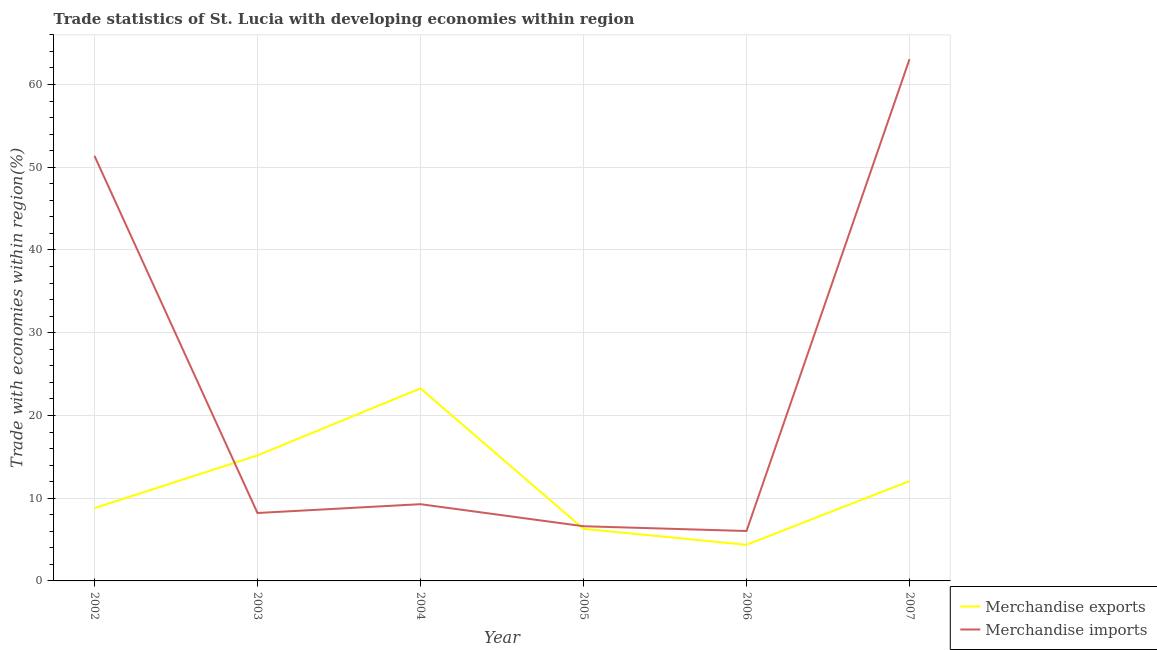How many different coloured lines are there?
Provide a succinct answer. 2. What is the merchandise exports in 2003?
Your answer should be very brief. 15.17. Across all years, what is the maximum merchandise exports?
Make the answer very short. 23.27. Across all years, what is the minimum merchandise exports?
Your answer should be very brief. 4.37. In which year was the merchandise imports maximum?
Make the answer very short. 2007. What is the total merchandise exports in the graph?
Give a very brief answer. 69.97. What is the difference between the merchandise exports in 2003 and that in 2007?
Give a very brief answer. 3.1. What is the difference between the merchandise exports in 2003 and the merchandise imports in 2007?
Offer a very short reply. -47.9. What is the average merchandise imports per year?
Your response must be concise. 24.1. In the year 2005, what is the difference between the merchandise exports and merchandise imports?
Give a very brief answer. -0.32. In how many years, is the merchandise imports greater than 58 %?
Provide a short and direct response. 1. What is the ratio of the merchandise imports in 2006 to that in 2007?
Provide a short and direct response. 0.1. Is the merchandise exports in 2005 less than that in 2006?
Keep it short and to the point. No. What is the difference between the highest and the second highest merchandise imports?
Ensure brevity in your answer.  11.69. What is the difference between the highest and the lowest merchandise exports?
Offer a very short reply. 18.9. In how many years, is the merchandise exports greater than the average merchandise exports taken over all years?
Give a very brief answer. 3. Does the merchandise imports monotonically increase over the years?
Offer a terse response. No. Where does the legend appear in the graph?
Your answer should be very brief. Bottom right. How are the legend labels stacked?
Keep it short and to the point. Vertical. What is the title of the graph?
Your response must be concise. Trade statistics of St. Lucia with developing economies within region. What is the label or title of the X-axis?
Provide a succinct answer. Year. What is the label or title of the Y-axis?
Offer a very short reply. Trade with economies within region(%). What is the Trade with economies within region(%) of Merchandise exports in 2002?
Offer a very short reply. 8.8. What is the Trade with economies within region(%) in Merchandise imports in 2002?
Keep it short and to the point. 51.38. What is the Trade with economies within region(%) of Merchandise exports in 2003?
Provide a succinct answer. 15.17. What is the Trade with economies within region(%) of Merchandise imports in 2003?
Give a very brief answer. 8.21. What is the Trade with economies within region(%) of Merchandise exports in 2004?
Give a very brief answer. 23.27. What is the Trade with economies within region(%) of Merchandise imports in 2004?
Give a very brief answer. 9.27. What is the Trade with economies within region(%) in Merchandise exports in 2005?
Keep it short and to the point. 6.3. What is the Trade with economies within region(%) of Merchandise imports in 2005?
Your answer should be very brief. 6.61. What is the Trade with economies within region(%) of Merchandise exports in 2006?
Provide a succinct answer. 4.37. What is the Trade with economies within region(%) of Merchandise imports in 2006?
Your answer should be compact. 6.03. What is the Trade with economies within region(%) in Merchandise exports in 2007?
Provide a succinct answer. 12.07. What is the Trade with economies within region(%) of Merchandise imports in 2007?
Your response must be concise. 63.07. Across all years, what is the maximum Trade with economies within region(%) of Merchandise exports?
Ensure brevity in your answer.  23.27. Across all years, what is the maximum Trade with economies within region(%) in Merchandise imports?
Ensure brevity in your answer.  63.07. Across all years, what is the minimum Trade with economies within region(%) in Merchandise exports?
Ensure brevity in your answer.  4.37. Across all years, what is the minimum Trade with economies within region(%) in Merchandise imports?
Make the answer very short. 6.03. What is the total Trade with economies within region(%) of Merchandise exports in the graph?
Your response must be concise. 69.97. What is the total Trade with economies within region(%) of Merchandise imports in the graph?
Your answer should be very brief. 144.57. What is the difference between the Trade with economies within region(%) in Merchandise exports in 2002 and that in 2003?
Provide a short and direct response. -6.37. What is the difference between the Trade with economies within region(%) in Merchandise imports in 2002 and that in 2003?
Ensure brevity in your answer.  43.17. What is the difference between the Trade with economies within region(%) of Merchandise exports in 2002 and that in 2004?
Your response must be concise. -14.47. What is the difference between the Trade with economies within region(%) of Merchandise imports in 2002 and that in 2004?
Your answer should be compact. 42.1. What is the difference between the Trade with economies within region(%) of Merchandise exports in 2002 and that in 2005?
Your answer should be compact. 2.5. What is the difference between the Trade with economies within region(%) of Merchandise imports in 2002 and that in 2005?
Make the answer very short. 44.77. What is the difference between the Trade with economies within region(%) of Merchandise exports in 2002 and that in 2006?
Offer a very short reply. 4.43. What is the difference between the Trade with economies within region(%) in Merchandise imports in 2002 and that in 2006?
Offer a very short reply. 45.35. What is the difference between the Trade with economies within region(%) in Merchandise exports in 2002 and that in 2007?
Your answer should be compact. -3.27. What is the difference between the Trade with economies within region(%) of Merchandise imports in 2002 and that in 2007?
Make the answer very short. -11.69. What is the difference between the Trade with economies within region(%) in Merchandise exports in 2003 and that in 2004?
Offer a very short reply. -8.1. What is the difference between the Trade with economies within region(%) of Merchandise imports in 2003 and that in 2004?
Keep it short and to the point. -1.06. What is the difference between the Trade with economies within region(%) of Merchandise exports in 2003 and that in 2005?
Offer a terse response. 8.88. What is the difference between the Trade with economies within region(%) in Merchandise imports in 2003 and that in 2005?
Offer a terse response. 1.6. What is the difference between the Trade with economies within region(%) of Merchandise exports in 2003 and that in 2006?
Your answer should be very brief. 10.8. What is the difference between the Trade with economies within region(%) in Merchandise imports in 2003 and that in 2006?
Offer a very short reply. 2.18. What is the difference between the Trade with economies within region(%) of Merchandise exports in 2003 and that in 2007?
Offer a terse response. 3.1. What is the difference between the Trade with economies within region(%) in Merchandise imports in 2003 and that in 2007?
Your answer should be compact. -54.86. What is the difference between the Trade with economies within region(%) of Merchandise exports in 2004 and that in 2005?
Make the answer very short. 16.97. What is the difference between the Trade with economies within region(%) in Merchandise imports in 2004 and that in 2005?
Provide a short and direct response. 2.66. What is the difference between the Trade with economies within region(%) in Merchandise exports in 2004 and that in 2006?
Your response must be concise. 18.9. What is the difference between the Trade with economies within region(%) in Merchandise imports in 2004 and that in 2006?
Your response must be concise. 3.24. What is the difference between the Trade with economies within region(%) in Merchandise exports in 2004 and that in 2007?
Give a very brief answer. 11.2. What is the difference between the Trade with economies within region(%) of Merchandise imports in 2004 and that in 2007?
Make the answer very short. -53.79. What is the difference between the Trade with economies within region(%) in Merchandise exports in 2005 and that in 2006?
Your answer should be compact. 1.93. What is the difference between the Trade with economies within region(%) of Merchandise imports in 2005 and that in 2006?
Your answer should be very brief. 0.58. What is the difference between the Trade with economies within region(%) of Merchandise exports in 2005 and that in 2007?
Your response must be concise. -5.77. What is the difference between the Trade with economies within region(%) of Merchandise imports in 2005 and that in 2007?
Your answer should be very brief. -56.46. What is the difference between the Trade with economies within region(%) in Merchandise exports in 2006 and that in 2007?
Offer a very short reply. -7.7. What is the difference between the Trade with economies within region(%) in Merchandise imports in 2006 and that in 2007?
Offer a very short reply. -57.03. What is the difference between the Trade with economies within region(%) of Merchandise exports in 2002 and the Trade with economies within region(%) of Merchandise imports in 2003?
Offer a terse response. 0.59. What is the difference between the Trade with economies within region(%) of Merchandise exports in 2002 and the Trade with economies within region(%) of Merchandise imports in 2004?
Your response must be concise. -0.48. What is the difference between the Trade with economies within region(%) in Merchandise exports in 2002 and the Trade with economies within region(%) in Merchandise imports in 2005?
Offer a very short reply. 2.19. What is the difference between the Trade with economies within region(%) in Merchandise exports in 2002 and the Trade with economies within region(%) in Merchandise imports in 2006?
Give a very brief answer. 2.76. What is the difference between the Trade with economies within region(%) in Merchandise exports in 2002 and the Trade with economies within region(%) in Merchandise imports in 2007?
Your answer should be very brief. -54.27. What is the difference between the Trade with economies within region(%) in Merchandise exports in 2003 and the Trade with economies within region(%) in Merchandise imports in 2004?
Your answer should be very brief. 5.9. What is the difference between the Trade with economies within region(%) in Merchandise exports in 2003 and the Trade with economies within region(%) in Merchandise imports in 2005?
Provide a succinct answer. 8.56. What is the difference between the Trade with economies within region(%) of Merchandise exports in 2003 and the Trade with economies within region(%) of Merchandise imports in 2006?
Give a very brief answer. 9.14. What is the difference between the Trade with economies within region(%) of Merchandise exports in 2003 and the Trade with economies within region(%) of Merchandise imports in 2007?
Keep it short and to the point. -47.9. What is the difference between the Trade with economies within region(%) of Merchandise exports in 2004 and the Trade with economies within region(%) of Merchandise imports in 2005?
Provide a short and direct response. 16.66. What is the difference between the Trade with economies within region(%) in Merchandise exports in 2004 and the Trade with economies within region(%) in Merchandise imports in 2006?
Provide a short and direct response. 17.23. What is the difference between the Trade with economies within region(%) of Merchandise exports in 2004 and the Trade with economies within region(%) of Merchandise imports in 2007?
Offer a terse response. -39.8. What is the difference between the Trade with economies within region(%) in Merchandise exports in 2005 and the Trade with economies within region(%) in Merchandise imports in 2006?
Provide a succinct answer. 0.26. What is the difference between the Trade with economies within region(%) of Merchandise exports in 2005 and the Trade with economies within region(%) of Merchandise imports in 2007?
Offer a very short reply. -56.77. What is the difference between the Trade with economies within region(%) of Merchandise exports in 2006 and the Trade with economies within region(%) of Merchandise imports in 2007?
Offer a terse response. -58.7. What is the average Trade with economies within region(%) in Merchandise exports per year?
Provide a short and direct response. 11.66. What is the average Trade with economies within region(%) of Merchandise imports per year?
Make the answer very short. 24.1. In the year 2002, what is the difference between the Trade with economies within region(%) in Merchandise exports and Trade with economies within region(%) in Merchandise imports?
Offer a very short reply. -42.58. In the year 2003, what is the difference between the Trade with economies within region(%) of Merchandise exports and Trade with economies within region(%) of Merchandise imports?
Your answer should be very brief. 6.96. In the year 2004, what is the difference between the Trade with economies within region(%) in Merchandise exports and Trade with economies within region(%) in Merchandise imports?
Your response must be concise. 13.99. In the year 2005, what is the difference between the Trade with economies within region(%) in Merchandise exports and Trade with economies within region(%) in Merchandise imports?
Offer a very short reply. -0.32. In the year 2006, what is the difference between the Trade with economies within region(%) of Merchandise exports and Trade with economies within region(%) of Merchandise imports?
Keep it short and to the point. -1.66. In the year 2007, what is the difference between the Trade with economies within region(%) in Merchandise exports and Trade with economies within region(%) in Merchandise imports?
Provide a succinct answer. -51. What is the ratio of the Trade with economies within region(%) of Merchandise exports in 2002 to that in 2003?
Your response must be concise. 0.58. What is the ratio of the Trade with economies within region(%) of Merchandise imports in 2002 to that in 2003?
Provide a short and direct response. 6.26. What is the ratio of the Trade with economies within region(%) in Merchandise exports in 2002 to that in 2004?
Give a very brief answer. 0.38. What is the ratio of the Trade with economies within region(%) in Merchandise imports in 2002 to that in 2004?
Provide a short and direct response. 5.54. What is the ratio of the Trade with economies within region(%) in Merchandise exports in 2002 to that in 2005?
Give a very brief answer. 1.4. What is the ratio of the Trade with economies within region(%) of Merchandise imports in 2002 to that in 2005?
Provide a succinct answer. 7.77. What is the ratio of the Trade with economies within region(%) of Merchandise exports in 2002 to that in 2006?
Your response must be concise. 2.01. What is the ratio of the Trade with economies within region(%) in Merchandise imports in 2002 to that in 2006?
Provide a short and direct response. 8.52. What is the ratio of the Trade with economies within region(%) of Merchandise exports in 2002 to that in 2007?
Keep it short and to the point. 0.73. What is the ratio of the Trade with economies within region(%) of Merchandise imports in 2002 to that in 2007?
Your answer should be compact. 0.81. What is the ratio of the Trade with economies within region(%) in Merchandise exports in 2003 to that in 2004?
Provide a succinct answer. 0.65. What is the ratio of the Trade with economies within region(%) of Merchandise imports in 2003 to that in 2004?
Keep it short and to the point. 0.89. What is the ratio of the Trade with economies within region(%) in Merchandise exports in 2003 to that in 2005?
Provide a short and direct response. 2.41. What is the ratio of the Trade with economies within region(%) of Merchandise imports in 2003 to that in 2005?
Make the answer very short. 1.24. What is the ratio of the Trade with economies within region(%) in Merchandise exports in 2003 to that in 2006?
Give a very brief answer. 3.47. What is the ratio of the Trade with economies within region(%) of Merchandise imports in 2003 to that in 2006?
Make the answer very short. 1.36. What is the ratio of the Trade with economies within region(%) in Merchandise exports in 2003 to that in 2007?
Make the answer very short. 1.26. What is the ratio of the Trade with economies within region(%) of Merchandise imports in 2003 to that in 2007?
Provide a short and direct response. 0.13. What is the ratio of the Trade with economies within region(%) of Merchandise exports in 2004 to that in 2005?
Offer a very short reply. 3.7. What is the ratio of the Trade with economies within region(%) of Merchandise imports in 2004 to that in 2005?
Offer a terse response. 1.4. What is the ratio of the Trade with economies within region(%) in Merchandise exports in 2004 to that in 2006?
Your answer should be compact. 5.33. What is the ratio of the Trade with economies within region(%) of Merchandise imports in 2004 to that in 2006?
Provide a short and direct response. 1.54. What is the ratio of the Trade with economies within region(%) of Merchandise exports in 2004 to that in 2007?
Offer a terse response. 1.93. What is the ratio of the Trade with economies within region(%) of Merchandise imports in 2004 to that in 2007?
Make the answer very short. 0.15. What is the ratio of the Trade with economies within region(%) in Merchandise exports in 2005 to that in 2006?
Offer a terse response. 1.44. What is the ratio of the Trade with economies within region(%) in Merchandise imports in 2005 to that in 2006?
Give a very brief answer. 1.1. What is the ratio of the Trade with economies within region(%) in Merchandise exports in 2005 to that in 2007?
Your answer should be compact. 0.52. What is the ratio of the Trade with economies within region(%) of Merchandise imports in 2005 to that in 2007?
Provide a succinct answer. 0.1. What is the ratio of the Trade with economies within region(%) of Merchandise exports in 2006 to that in 2007?
Provide a short and direct response. 0.36. What is the ratio of the Trade with economies within region(%) in Merchandise imports in 2006 to that in 2007?
Your answer should be compact. 0.1. What is the difference between the highest and the second highest Trade with economies within region(%) in Merchandise exports?
Provide a succinct answer. 8.1. What is the difference between the highest and the second highest Trade with economies within region(%) of Merchandise imports?
Provide a short and direct response. 11.69. What is the difference between the highest and the lowest Trade with economies within region(%) of Merchandise exports?
Provide a succinct answer. 18.9. What is the difference between the highest and the lowest Trade with economies within region(%) in Merchandise imports?
Your answer should be compact. 57.03. 